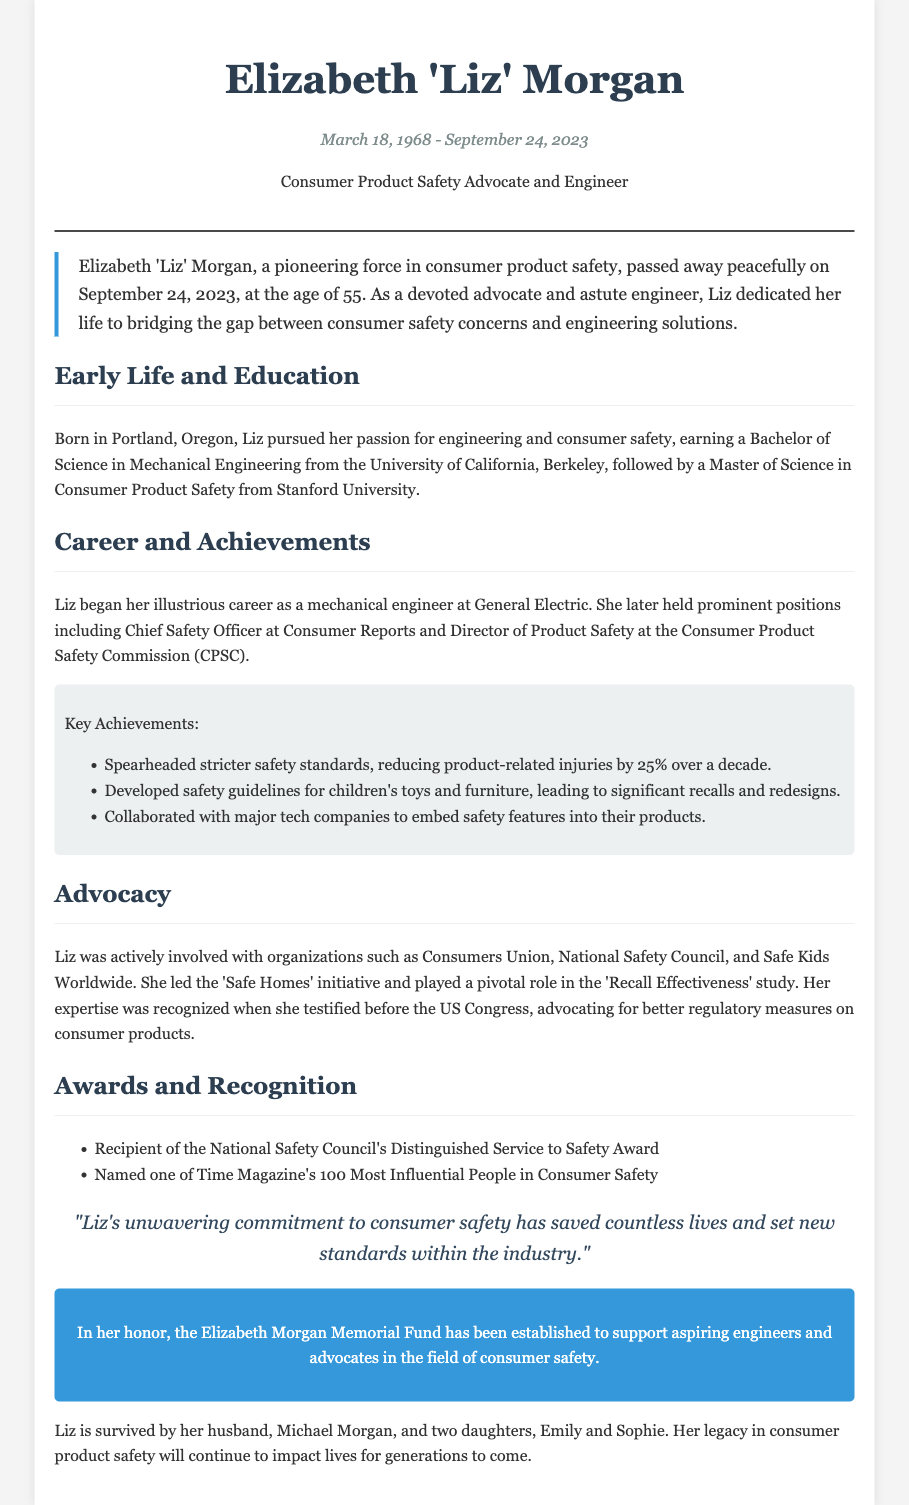What is Liz Morgan's full name? The document states her full name as "Elizabeth 'Liz' Morgan."
Answer: Elizabeth 'Liz' Morgan What was Liz Morgan's age at the time of her passing? The document mentions that Liz passed away at the age of 55.
Answer: 55 Where did Liz earn her Bachelor of Science degree? The document specifies that she earned her degree from the University of California, Berkeley.
Answer: University of California, Berkeley What significant impact did Liz have on product-related injuries? The document notes that she reduced product-related injuries by 25% over a decade.
Answer: 25% Which award did Liz receive from the National Safety Council? The document lists her as a recipient of the Distinguished Service to Safety Award.
Answer: Distinguished Service to Safety Award What initiative did Liz lead related to consumer safety? The document indicates that Liz led the 'Safe Homes' initiative.
Answer: Safe Homes What is the name of the memorial fund established in Liz's honor? The document states the memorial fund is named the Elizabeth Morgan Memorial Fund.
Answer: Elizabeth Morgan Memorial Fund Who are the surviving family members of Liz? The document mentions her husband, Michael Morgan, and two daughters, Emily and Sophie.
Answer: Michael Morgan, Emily, and Sophie 